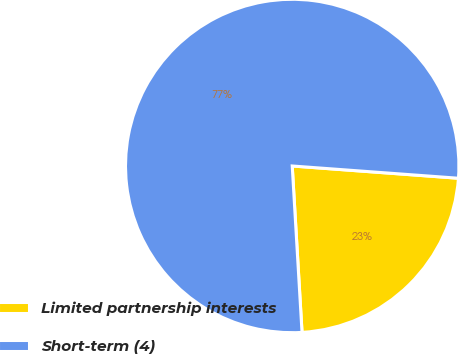Convert chart. <chart><loc_0><loc_0><loc_500><loc_500><pie_chart><fcel>Limited partnership interests<fcel>Short-term (4)<nl><fcel>22.89%<fcel>77.11%<nl></chart> 